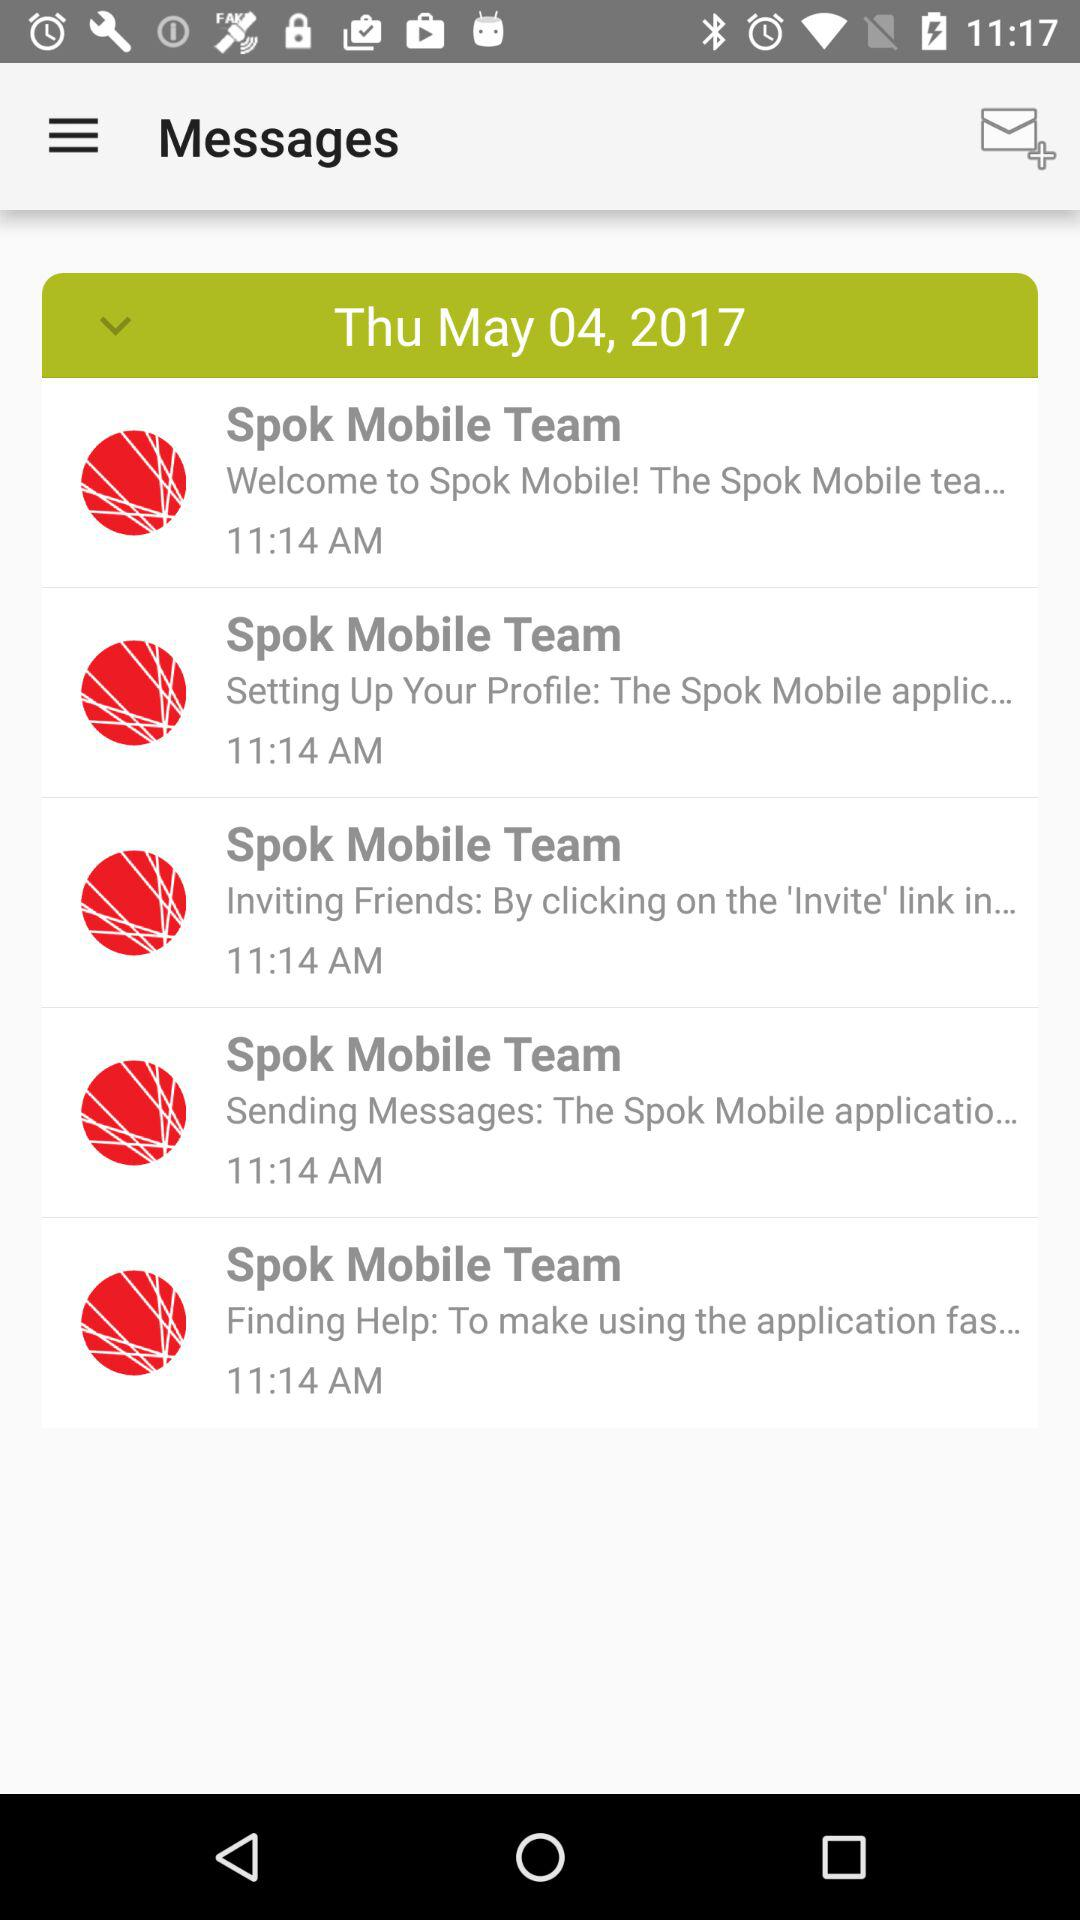What is the given date? The given date is Thursday, May 4, 2017. 